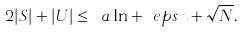<formula> <loc_0><loc_0><loc_500><loc_500>2 | S | + | U | \leq \ a \ln + \ e p s n + \sqrt { N } .</formula> 